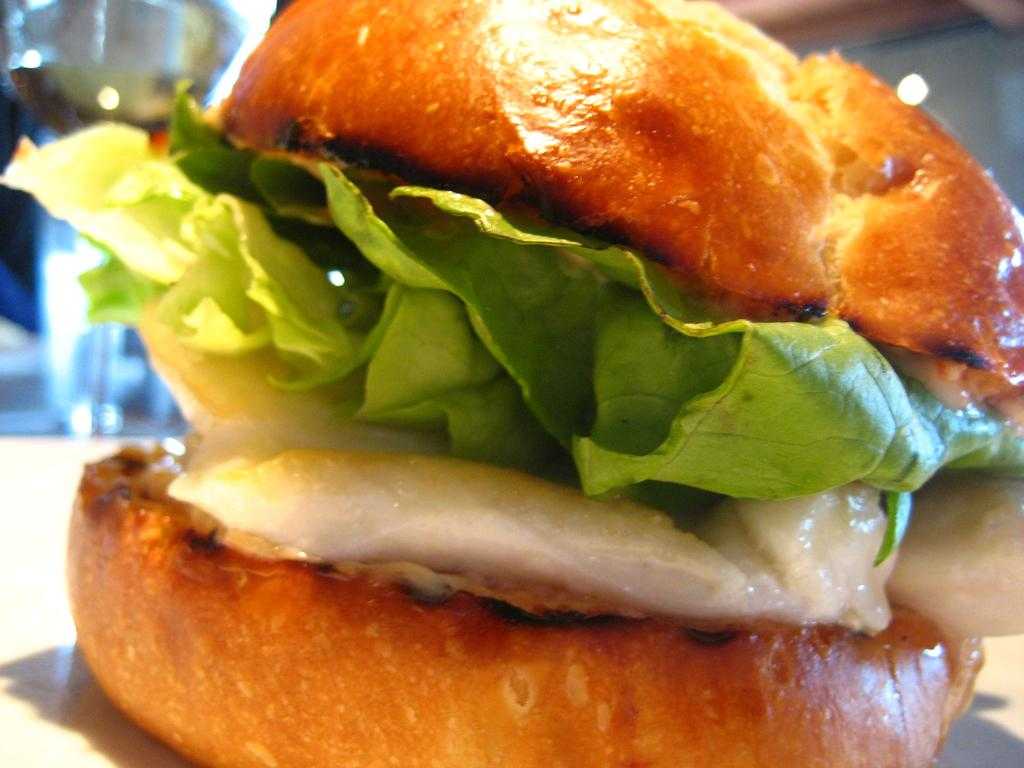What type of food is visible in the image? There is a burger in the image. Can you describe the background of the image? The background of the image is blurry. What type of glass is being used by the maid in the image? There is no glass or maid present in the image; it only features a burger with a blurry background. 